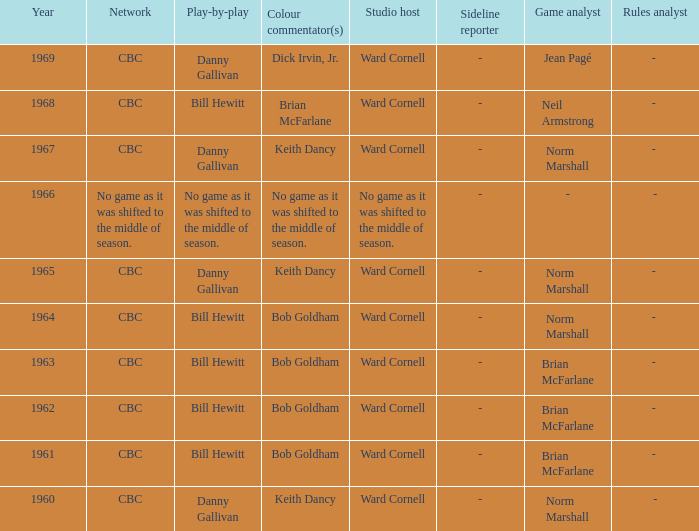Who did the play-by-play with studio host Ward Cornell and color commentator Bob Goldham? Bill Hewitt, Bill Hewitt, Bill Hewitt, Bill Hewitt. 